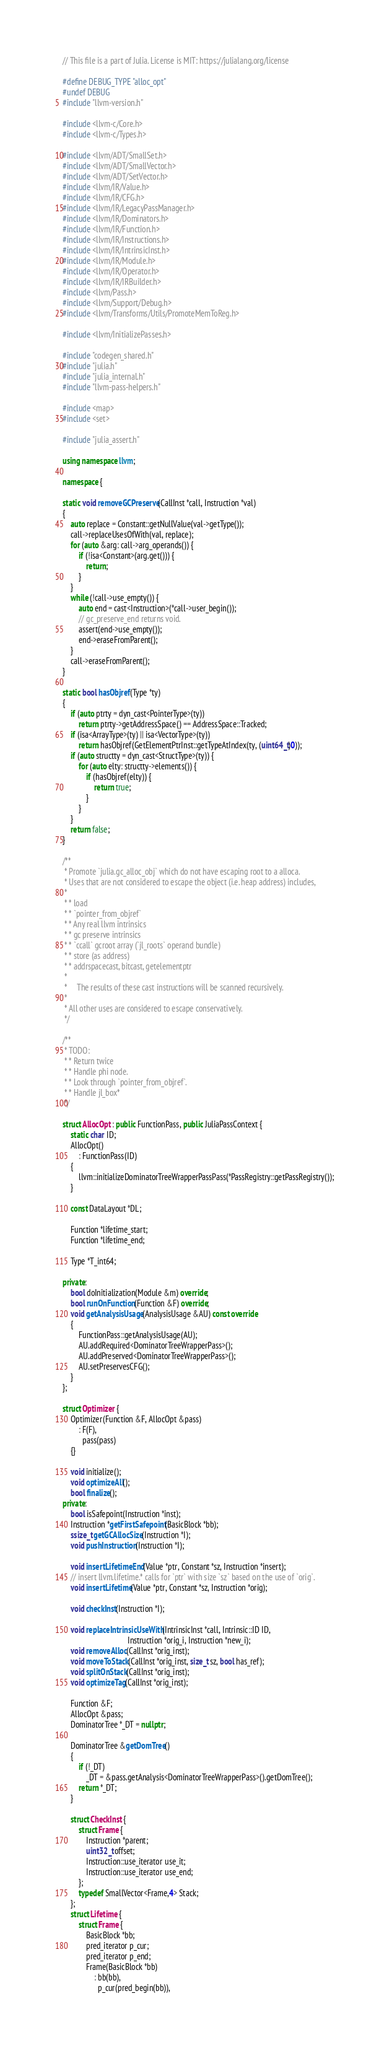<code> <loc_0><loc_0><loc_500><loc_500><_C++_>// This file is a part of Julia. License is MIT: https://julialang.org/license

#define DEBUG_TYPE "alloc_opt"
#undef DEBUG
#include "llvm-version.h"

#include <llvm-c/Core.h>
#include <llvm-c/Types.h>

#include <llvm/ADT/SmallSet.h>
#include <llvm/ADT/SmallVector.h>
#include <llvm/ADT/SetVector.h>
#include <llvm/IR/Value.h>
#include <llvm/IR/CFG.h>
#include <llvm/IR/LegacyPassManager.h>
#include <llvm/IR/Dominators.h>
#include <llvm/IR/Function.h>
#include <llvm/IR/Instructions.h>
#include <llvm/IR/IntrinsicInst.h>
#include <llvm/IR/Module.h>
#include <llvm/IR/Operator.h>
#include <llvm/IR/IRBuilder.h>
#include <llvm/Pass.h>
#include <llvm/Support/Debug.h>
#include <llvm/Transforms/Utils/PromoteMemToReg.h>

#include <llvm/InitializePasses.h>

#include "codegen_shared.h"
#include "julia.h"
#include "julia_internal.h"
#include "llvm-pass-helpers.h"

#include <map>
#include <set>

#include "julia_assert.h"

using namespace llvm;

namespace {

static void removeGCPreserve(CallInst *call, Instruction *val)
{
    auto replace = Constant::getNullValue(val->getType());
    call->replaceUsesOfWith(val, replace);
    for (auto &arg: call->arg_operands()) {
        if (!isa<Constant>(arg.get())) {
            return;
        }
    }
    while (!call->use_empty()) {
        auto end = cast<Instruction>(*call->user_begin());
        // gc_preserve_end returns void.
        assert(end->use_empty());
        end->eraseFromParent();
    }
    call->eraseFromParent();
}

static bool hasObjref(Type *ty)
{
    if (auto ptrty = dyn_cast<PointerType>(ty))
        return ptrty->getAddressSpace() == AddressSpace::Tracked;
    if (isa<ArrayType>(ty) || isa<VectorType>(ty))
        return hasObjref(GetElementPtrInst::getTypeAtIndex(ty, (uint64_t)0));
    if (auto structty = dyn_cast<StructType>(ty)) {
        for (auto elty: structty->elements()) {
            if (hasObjref(elty)) {
                return true;
            }
        }
    }
    return false;
}

/**
 * Promote `julia.gc_alloc_obj` which do not have escaping root to a alloca.
 * Uses that are not considered to escape the object (i.e. heap address) includes,
 *
 * * load
 * * `pointer_from_objref`
 * * Any real llvm intrinsics
 * * gc preserve intrinsics
 * * `ccall` gcroot array (`jl_roots` operand bundle)
 * * store (as address)
 * * addrspacecast, bitcast, getelementptr
 *
 *     The results of these cast instructions will be scanned recursively.
 *
 * All other uses are considered to escape conservatively.
 */

/**
 * TODO:
 * * Return twice
 * * Handle phi node.
 * * Look through `pointer_from_objref`.
 * * Handle jl_box*
 */

struct AllocOpt : public FunctionPass, public JuliaPassContext {
    static char ID;
    AllocOpt()
        : FunctionPass(ID)
    {
        llvm::initializeDominatorTreeWrapperPassPass(*PassRegistry::getPassRegistry());
    }

    const DataLayout *DL;

    Function *lifetime_start;
    Function *lifetime_end;

    Type *T_int64;

private:
    bool doInitialization(Module &m) override;
    bool runOnFunction(Function &F) override;
    void getAnalysisUsage(AnalysisUsage &AU) const override
    {
        FunctionPass::getAnalysisUsage(AU);
        AU.addRequired<DominatorTreeWrapperPass>();
        AU.addPreserved<DominatorTreeWrapperPass>();
        AU.setPreservesCFG();
    }
};

struct Optimizer {
    Optimizer(Function &F, AllocOpt &pass)
        : F(F),
          pass(pass)
    {}

    void initialize();
    void optimizeAll();
    bool finalize();
private:
    bool isSafepoint(Instruction *inst);
    Instruction *getFirstSafepoint(BasicBlock *bb);
    ssize_t getGCAllocSize(Instruction *I);
    void pushInstruction(Instruction *I);

    void insertLifetimeEnd(Value *ptr, Constant *sz, Instruction *insert);
    // insert llvm.lifetime.* calls for `ptr` with size `sz` based on the use of `orig`.
    void insertLifetime(Value *ptr, Constant *sz, Instruction *orig);

    void checkInst(Instruction *I);

    void replaceIntrinsicUseWith(IntrinsicInst *call, Intrinsic::ID ID,
                                 Instruction *orig_i, Instruction *new_i);
    void removeAlloc(CallInst *orig_inst);
    void moveToStack(CallInst *orig_inst, size_t sz, bool has_ref);
    void splitOnStack(CallInst *orig_inst);
    void optimizeTag(CallInst *orig_inst);

    Function &F;
    AllocOpt &pass;
    DominatorTree *_DT = nullptr;

    DominatorTree &getDomTree()
    {
        if (!_DT)
            _DT = &pass.getAnalysis<DominatorTreeWrapperPass>().getDomTree();
        return *_DT;
    }

    struct CheckInst {
        struct Frame {
            Instruction *parent;
            uint32_t offset;
            Instruction::use_iterator use_it;
            Instruction::use_iterator use_end;
        };
        typedef SmallVector<Frame,4> Stack;
    };
    struct Lifetime {
        struct Frame {
            BasicBlock *bb;
            pred_iterator p_cur;
            pred_iterator p_end;
            Frame(BasicBlock *bb)
                : bb(bb),
                  p_cur(pred_begin(bb)),</code> 